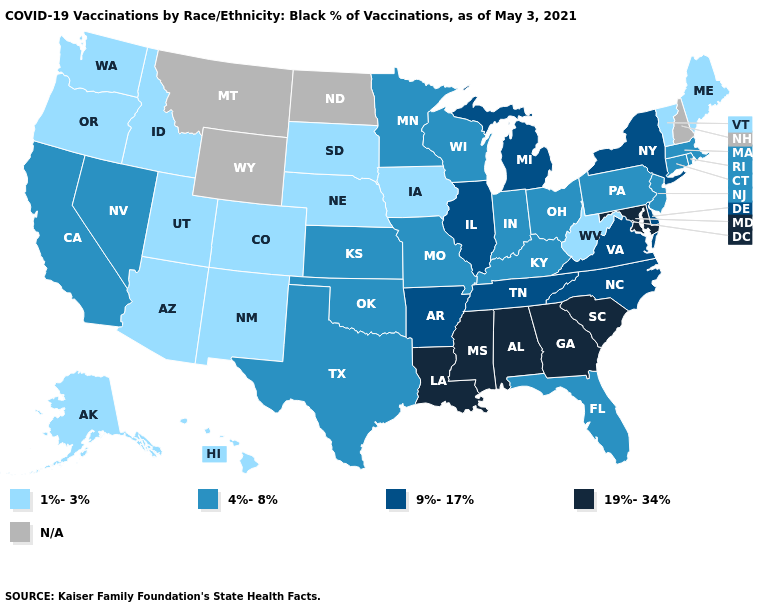Which states hav the highest value in the Northeast?
Keep it brief. New York. Which states have the lowest value in the USA?
Concise answer only. Alaska, Arizona, Colorado, Hawaii, Idaho, Iowa, Maine, Nebraska, New Mexico, Oregon, South Dakota, Utah, Vermont, Washington, West Virginia. Name the states that have a value in the range 4%-8%?
Write a very short answer. California, Connecticut, Florida, Indiana, Kansas, Kentucky, Massachusetts, Minnesota, Missouri, Nevada, New Jersey, Ohio, Oklahoma, Pennsylvania, Rhode Island, Texas, Wisconsin. What is the value of Louisiana?
Short answer required. 19%-34%. What is the lowest value in the USA?
Give a very brief answer. 1%-3%. Is the legend a continuous bar?
Concise answer only. No. Which states have the lowest value in the USA?
Concise answer only. Alaska, Arizona, Colorado, Hawaii, Idaho, Iowa, Maine, Nebraska, New Mexico, Oregon, South Dakota, Utah, Vermont, Washington, West Virginia. What is the value of New York?
Quick response, please. 9%-17%. Which states have the highest value in the USA?
Concise answer only. Alabama, Georgia, Louisiana, Maryland, Mississippi, South Carolina. What is the lowest value in the MidWest?
Answer briefly. 1%-3%. What is the lowest value in the USA?
Answer briefly. 1%-3%. What is the value of Hawaii?
Concise answer only. 1%-3%. Does Idaho have the lowest value in the USA?
Keep it brief. Yes. Name the states that have a value in the range 9%-17%?
Keep it brief. Arkansas, Delaware, Illinois, Michigan, New York, North Carolina, Tennessee, Virginia. What is the highest value in the South ?
Quick response, please. 19%-34%. 